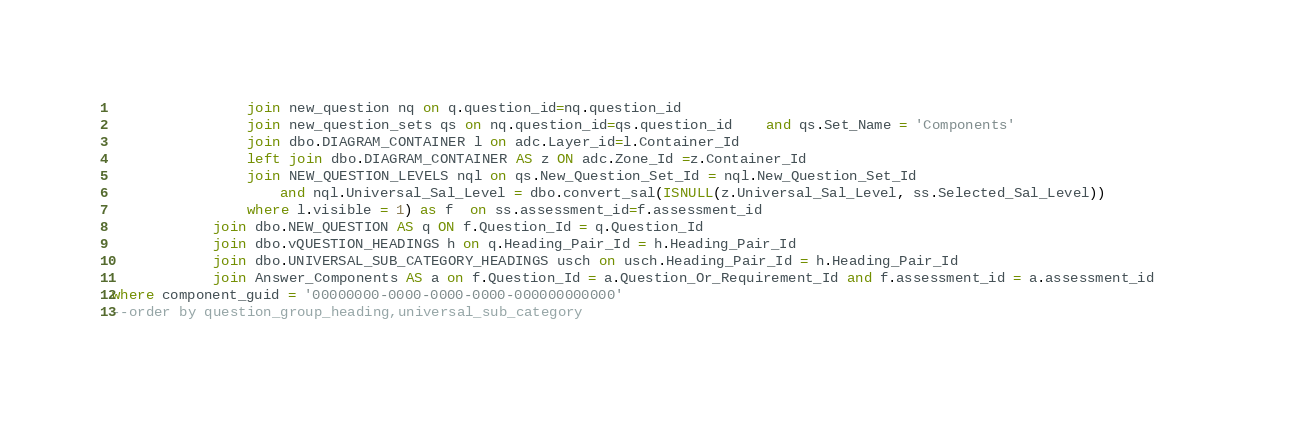<code> <loc_0><loc_0><loc_500><loc_500><_SQL_>				join new_question nq on q.question_id=nq.question_id		
				join new_question_sets qs on nq.question_id=qs.question_id	and qs.Set_Name = 'Components'		
				join dbo.DIAGRAM_CONTAINER l on adc.Layer_id=l.Container_Id
				left join dbo.DIAGRAM_CONTAINER AS z ON adc.Zone_Id =z.Container_Id
				join NEW_QUESTION_LEVELS nql on qs.New_Question_Set_Id = nql.New_Question_Set_Id 
					and nql.Universal_Sal_Level = dbo.convert_sal(ISNULL(z.Universal_Sal_Level, ss.Selected_Sal_Level))
				where l.visible = 1) as f  on ss.assessment_id=f.assessment_id							
            join dbo.NEW_QUESTION AS q ON f.Question_Id = q.Question_Id 
			join dbo.vQUESTION_HEADINGS h on q.Heading_Pair_Id = h.Heading_Pair_Id	
			join dbo.UNIVERSAL_SUB_CATEGORY_HEADINGS usch on usch.Heading_Pair_Id = h.Heading_Pair_Id		    
			join Answer_Components AS a on f.Question_Id = a.Question_Or_Requirement_Id and f.assessment_id = a.assessment_id	  
where component_guid = '00000000-0000-0000-0000-000000000000'
--order by question_group_heading,universal_sub_category
</code> 